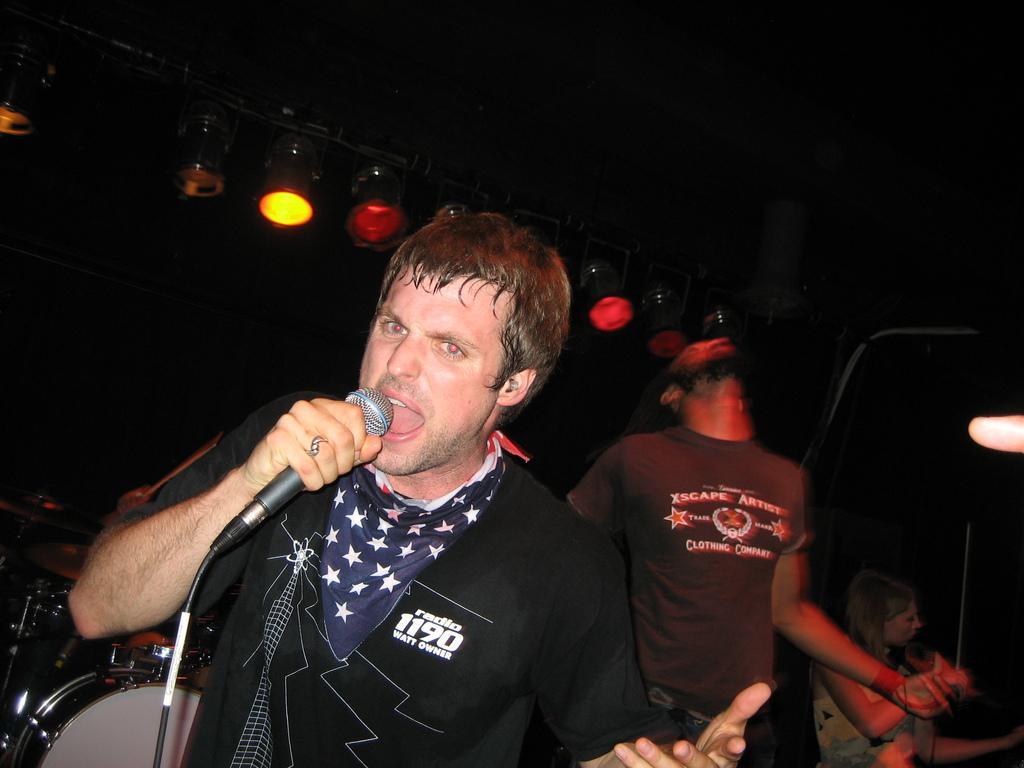Could you give a brief overview of what you see in this image? This is a band performing live. In the center of the picture there is a person singing holding a microphone. On the left there are drums. In the background there are focus light. In the background there is a person standing. On the right there is a woman sitting. Background is dark. 